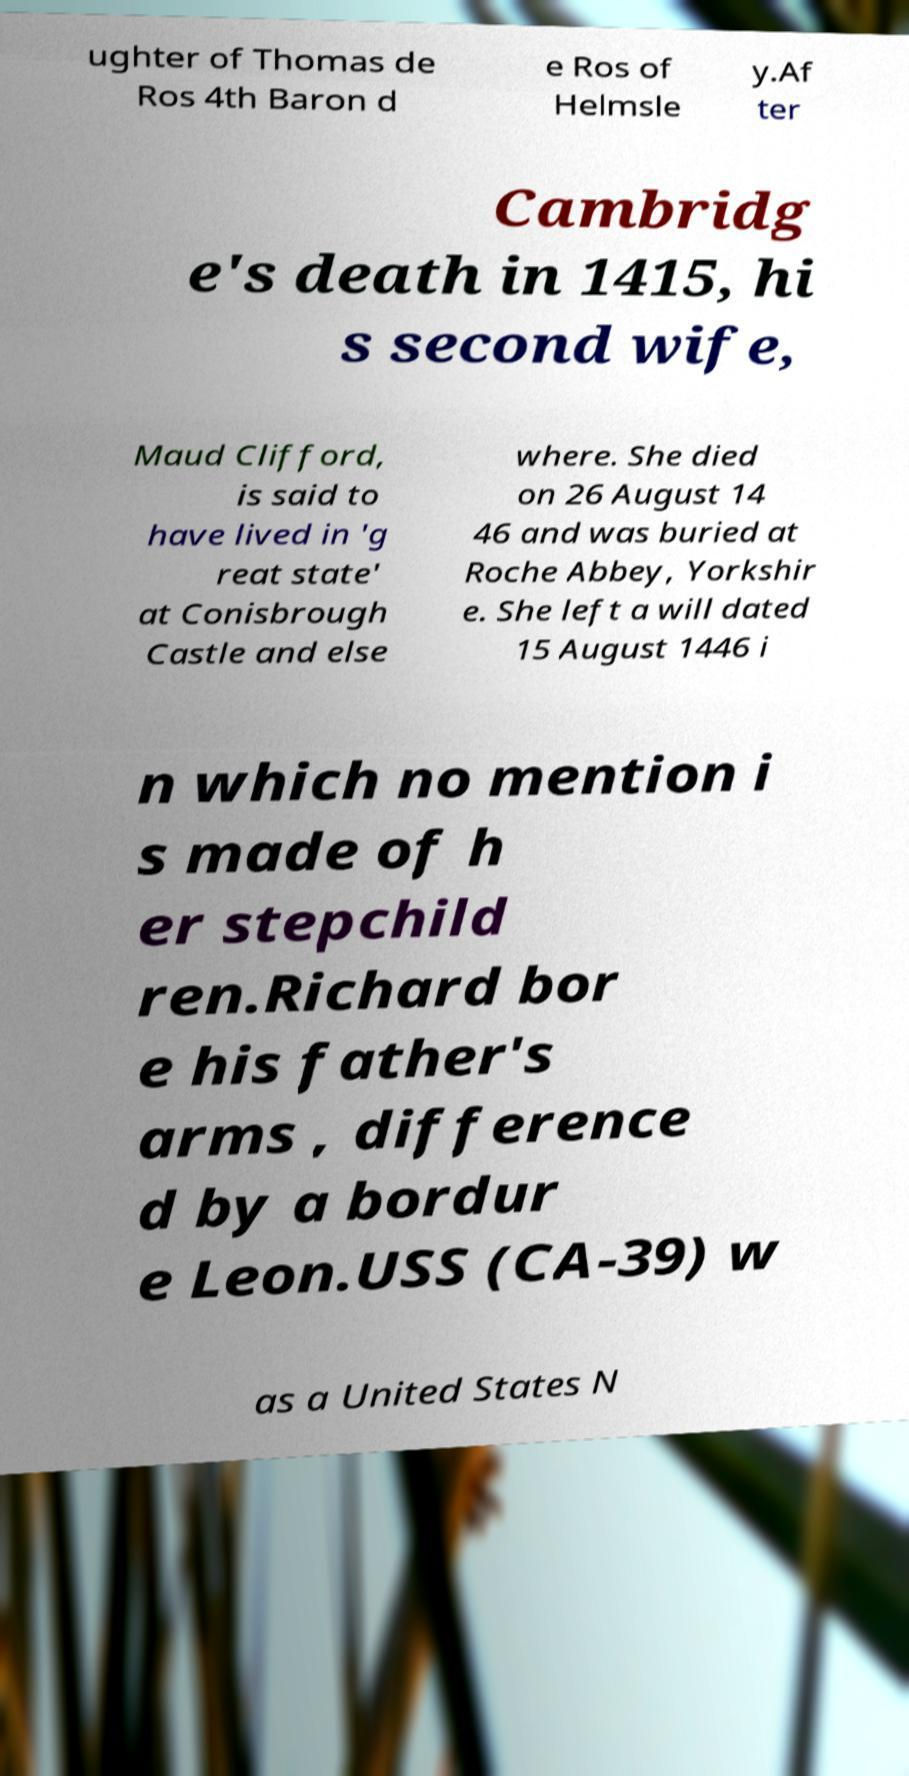I need the written content from this picture converted into text. Can you do that? ughter of Thomas de Ros 4th Baron d e Ros of Helmsle y.Af ter Cambridg e's death in 1415, hi s second wife, Maud Clifford, is said to have lived in 'g reat state' at Conisbrough Castle and else where. She died on 26 August 14 46 and was buried at Roche Abbey, Yorkshir e. She left a will dated 15 August 1446 i n which no mention i s made of h er stepchild ren.Richard bor e his father's arms , difference d by a bordur e Leon.USS (CA-39) w as a United States N 